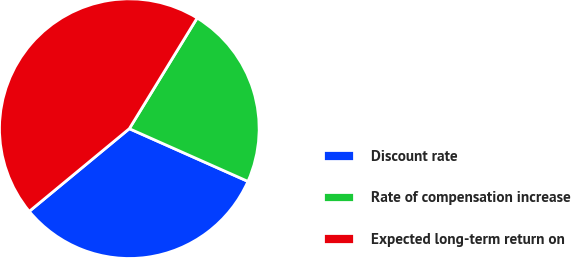Convert chart. <chart><loc_0><loc_0><loc_500><loc_500><pie_chart><fcel>Discount rate<fcel>Rate of compensation increase<fcel>Expected long-term return on<nl><fcel>32.35%<fcel>22.91%<fcel>44.74%<nl></chart> 